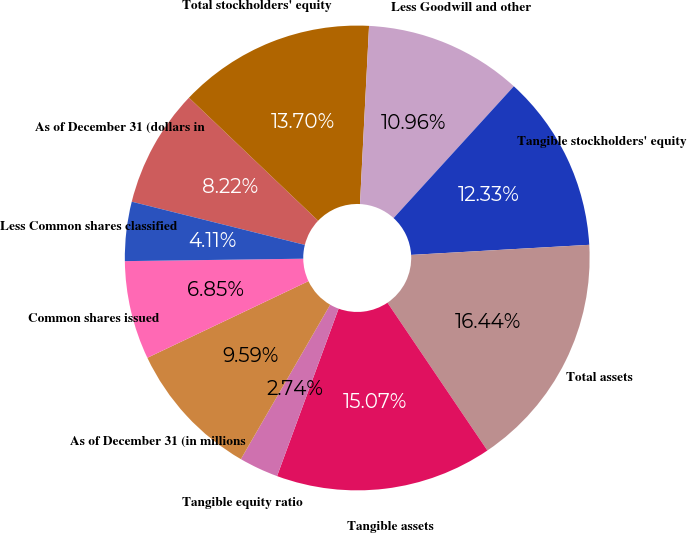<chart> <loc_0><loc_0><loc_500><loc_500><pie_chart><fcel>As of December 31 (dollars in<fcel>Total stockholders' equity<fcel>Less Goodwill and other<fcel>Tangible stockholders' equity<fcel>Total assets<fcel>Tangible assets<fcel>Tangible equity ratio<fcel>As of December 31 (in millions<fcel>Common shares issued<fcel>Less Common shares classified<nl><fcel>8.22%<fcel>13.7%<fcel>10.96%<fcel>12.33%<fcel>16.44%<fcel>15.07%<fcel>2.74%<fcel>9.59%<fcel>6.85%<fcel>4.11%<nl></chart> 